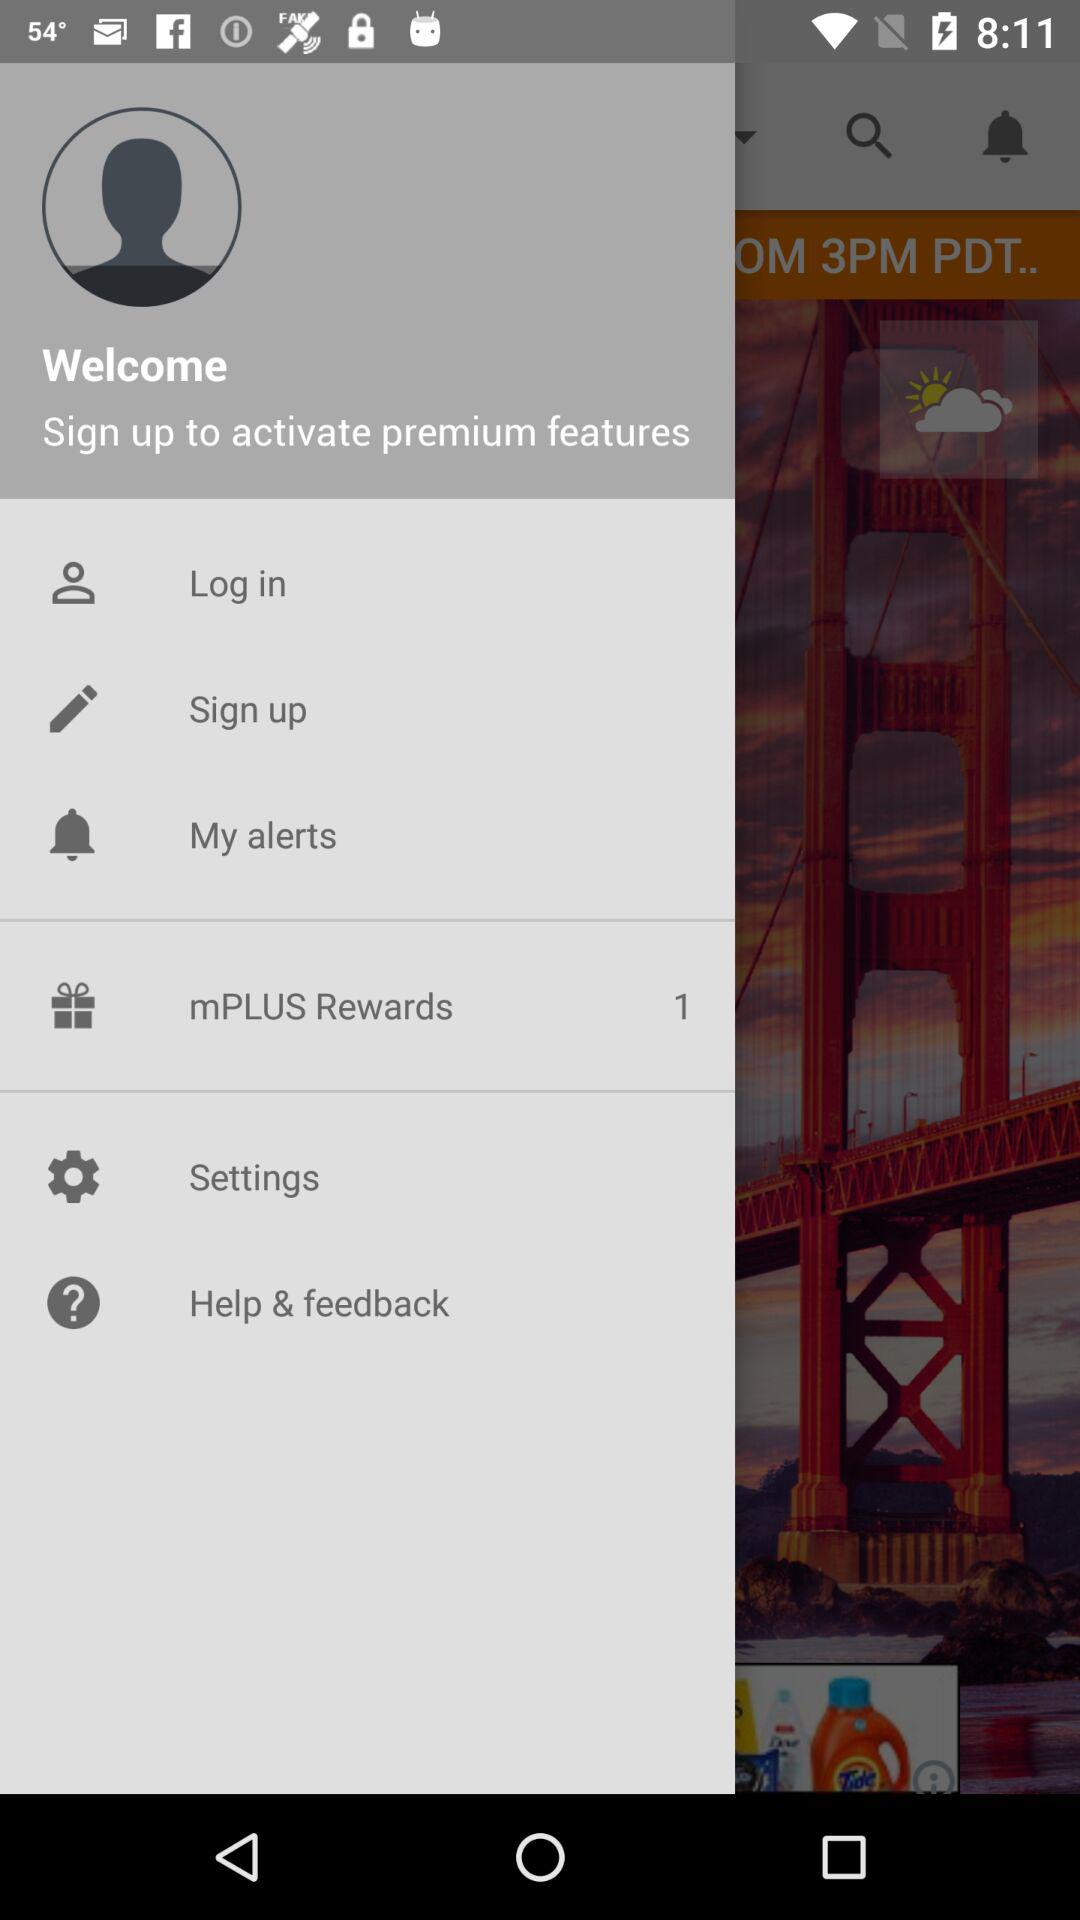How many mPLUS Rewards are there? There is 1 mPLUS Reward. 